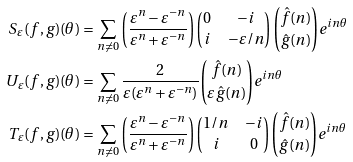<formula> <loc_0><loc_0><loc_500><loc_500>S _ { \varepsilon } ( f , g ) ( \theta ) & = \sum _ { n \neq 0 } \left ( \frac { \varepsilon ^ { n } - \varepsilon ^ { - n } } { \varepsilon ^ { n } + \varepsilon ^ { - n } } \right ) \left ( \begin{matrix} 0 & - i \\ i & - \varepsilon / n \end{matrix} \right ) { \hat { f } ( n ) \choose \hat { g } ( n ) } e ^ { i n \theta } \\ U _ { \varepsilon } ( f , g ) ( \theta ) & = \sum _ { n \neq 0 } \frac { 2 } { \varepsilon ( \varepsilon ^ { n } + \varepsilon ^ { - n } ) } { \hat { f } ( n ) \choose \varepsilon \hat { g } ( n ) } e ^ { i n \theta } \\ T _ { \varepsilon } ( f , g ) ( \theta ) & = \sum _ { n \neq 0 } \left ( \frac { \varepsilon ^ { n } - \varepsilon ^ { - n } } { \varepsilon ^ { n } + \varepsilon ^ { - n } } \right ) \left ( \begin{matrix} 1 / n & - i \\ i & 0 \end{matrix} \right ) { \hat { f } ( n ) \choose \hat { g } ( n ) } e ^ { i n \theta }</formula> 